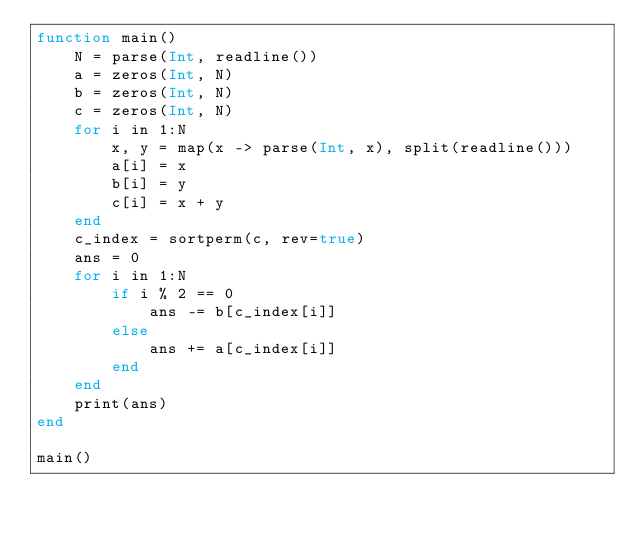Convert code to text. <code><loc_0><loc_0><loc_500><loc_500><_Julia_>function main()
    N = parse(Int, readline()) 
    a = zeros(Int, N)
    b = zeros(Int, N)
    c = zeros(Int, N)
    for i in 1:N
        x, y = map(x -> parse(Int, x), split(readline()))
        a[i] = x
        b[i] = y
        c[i] = x + y
    end
    c_index = sortperm(c, rev=true)
    ans = 0
    for i in 1:N
        if i % 2 == 0
            ans -= b[c_index[i]]
        else
            ans += a[c_index[i]]
        end
    end
    print(ans)
end

main()</code> 